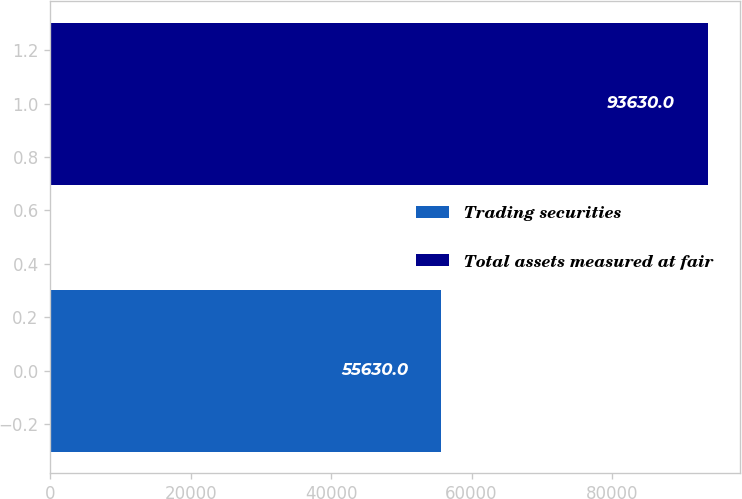Convert chart. <chart><loc_0><loc_0><loc_500><loc_500><bar_chart><fcel>Trading securities<fcel>Total assets measured at fair<nl><fcel>55630<fcel>93630<nl></chart> 